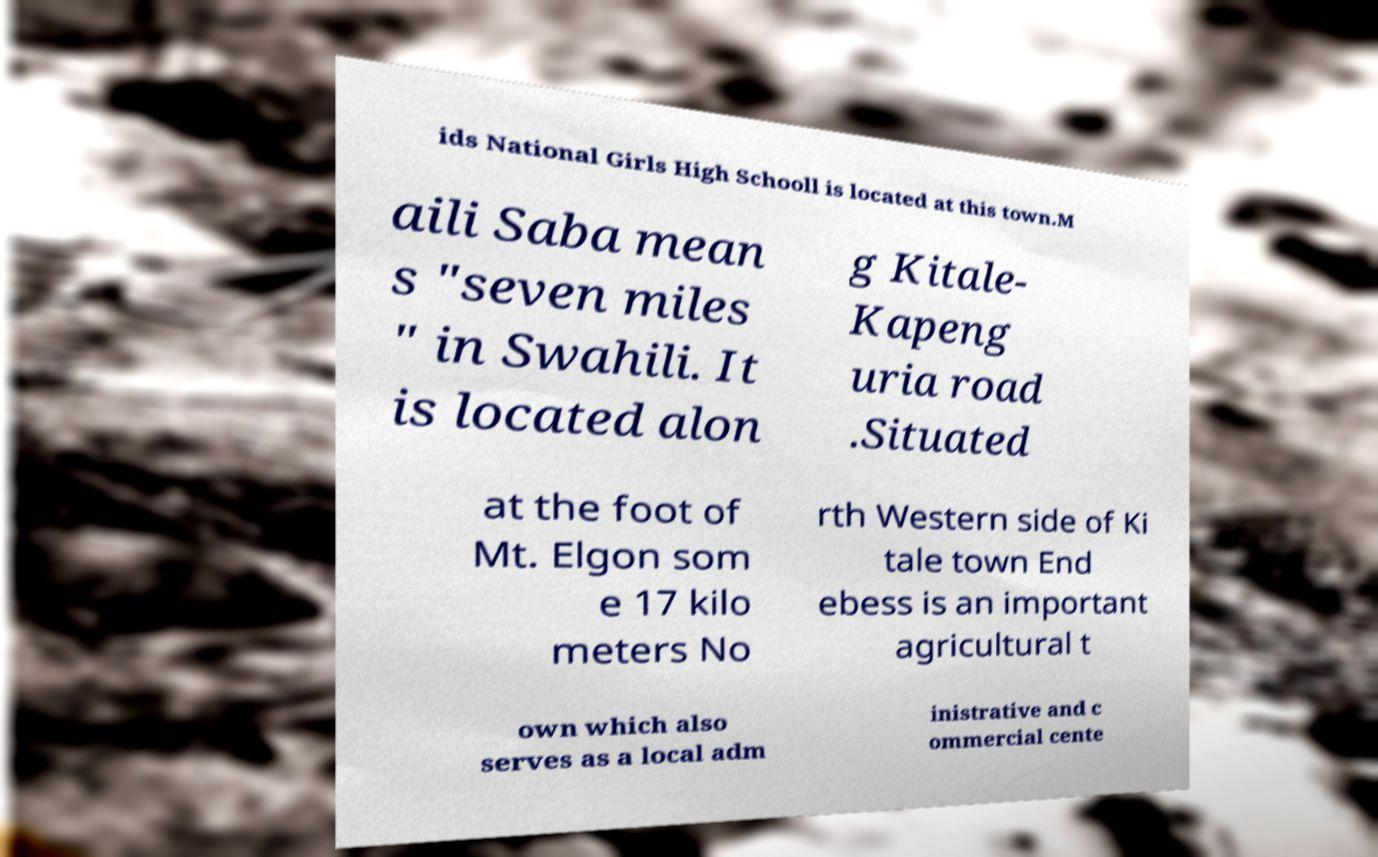I need the written content from this picture converted into text. Can you do that? ids National Girls High Schooll is located at this town.M aili Saba mean s "seven miles " in Swahili. It is located alon g Kitale- Kapeng uria road .Situated at the foot of Mt. Elgon som e 17 kilo meters No rth Western side of Ki tale town End ebess is an important agricultural t own which also serves as a local adm inistrative and c ommercial cente 